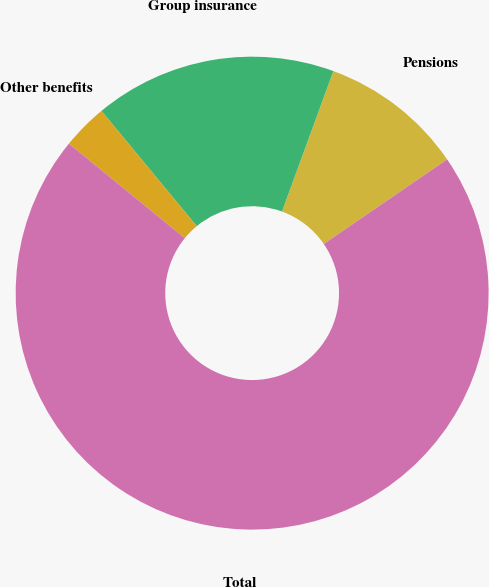Convert chart. <chart><loc_0><loc_0><loc_500><loc_500><pie_chart><fcel>Pensions<fcel>Group insurance<fcel>Other benefits<fcel>Total<nl><fcel>9.85%<fcel>16.58%<fcel>3.11%<fcel>70.46%<nl></chart> 